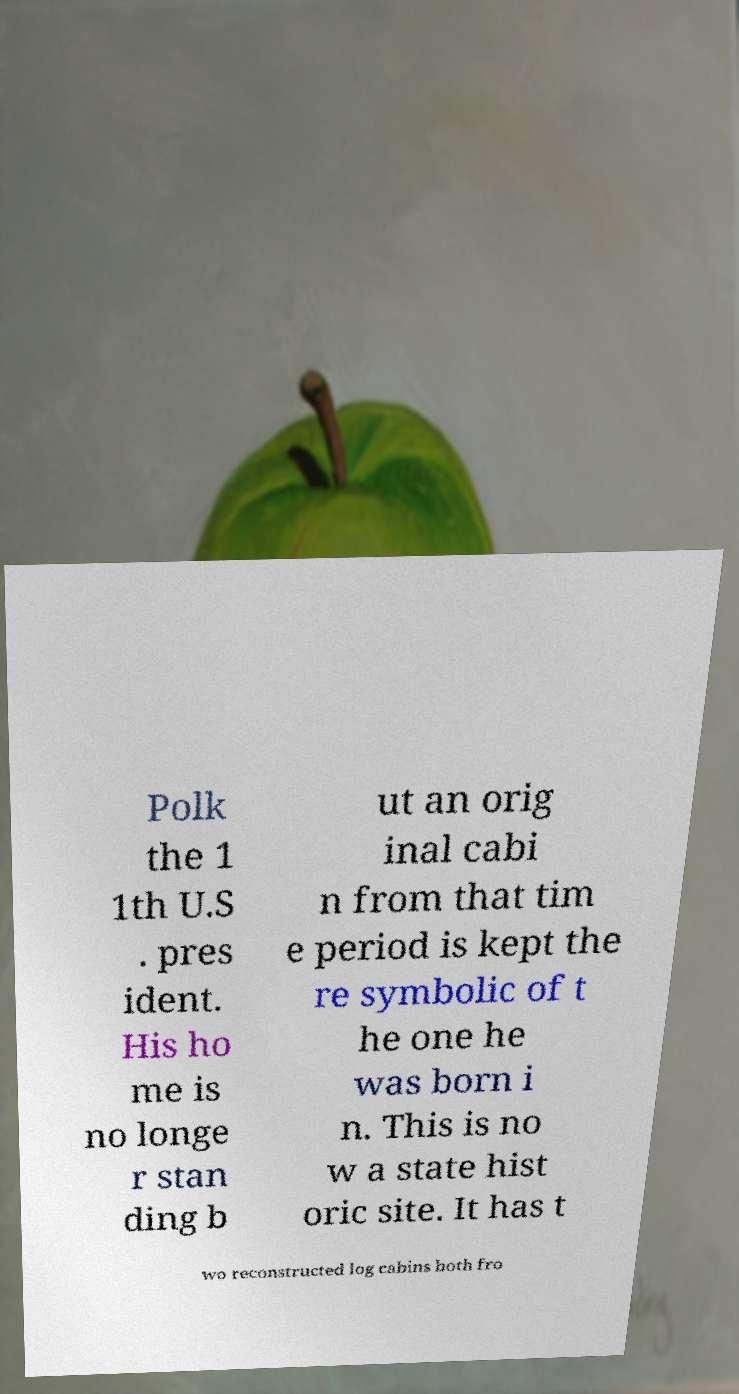Can you accurately transcribe the text from the provided image for me? Polk the 1 1th U.S . pres ident. His ho me is no longe r stan ding b ut an orig inal cabi n from that tim e period is kept the re symbolic of t he one he was born i n. This is no w a state hist oric site. It has t wo reconstructed log cabins both fro 